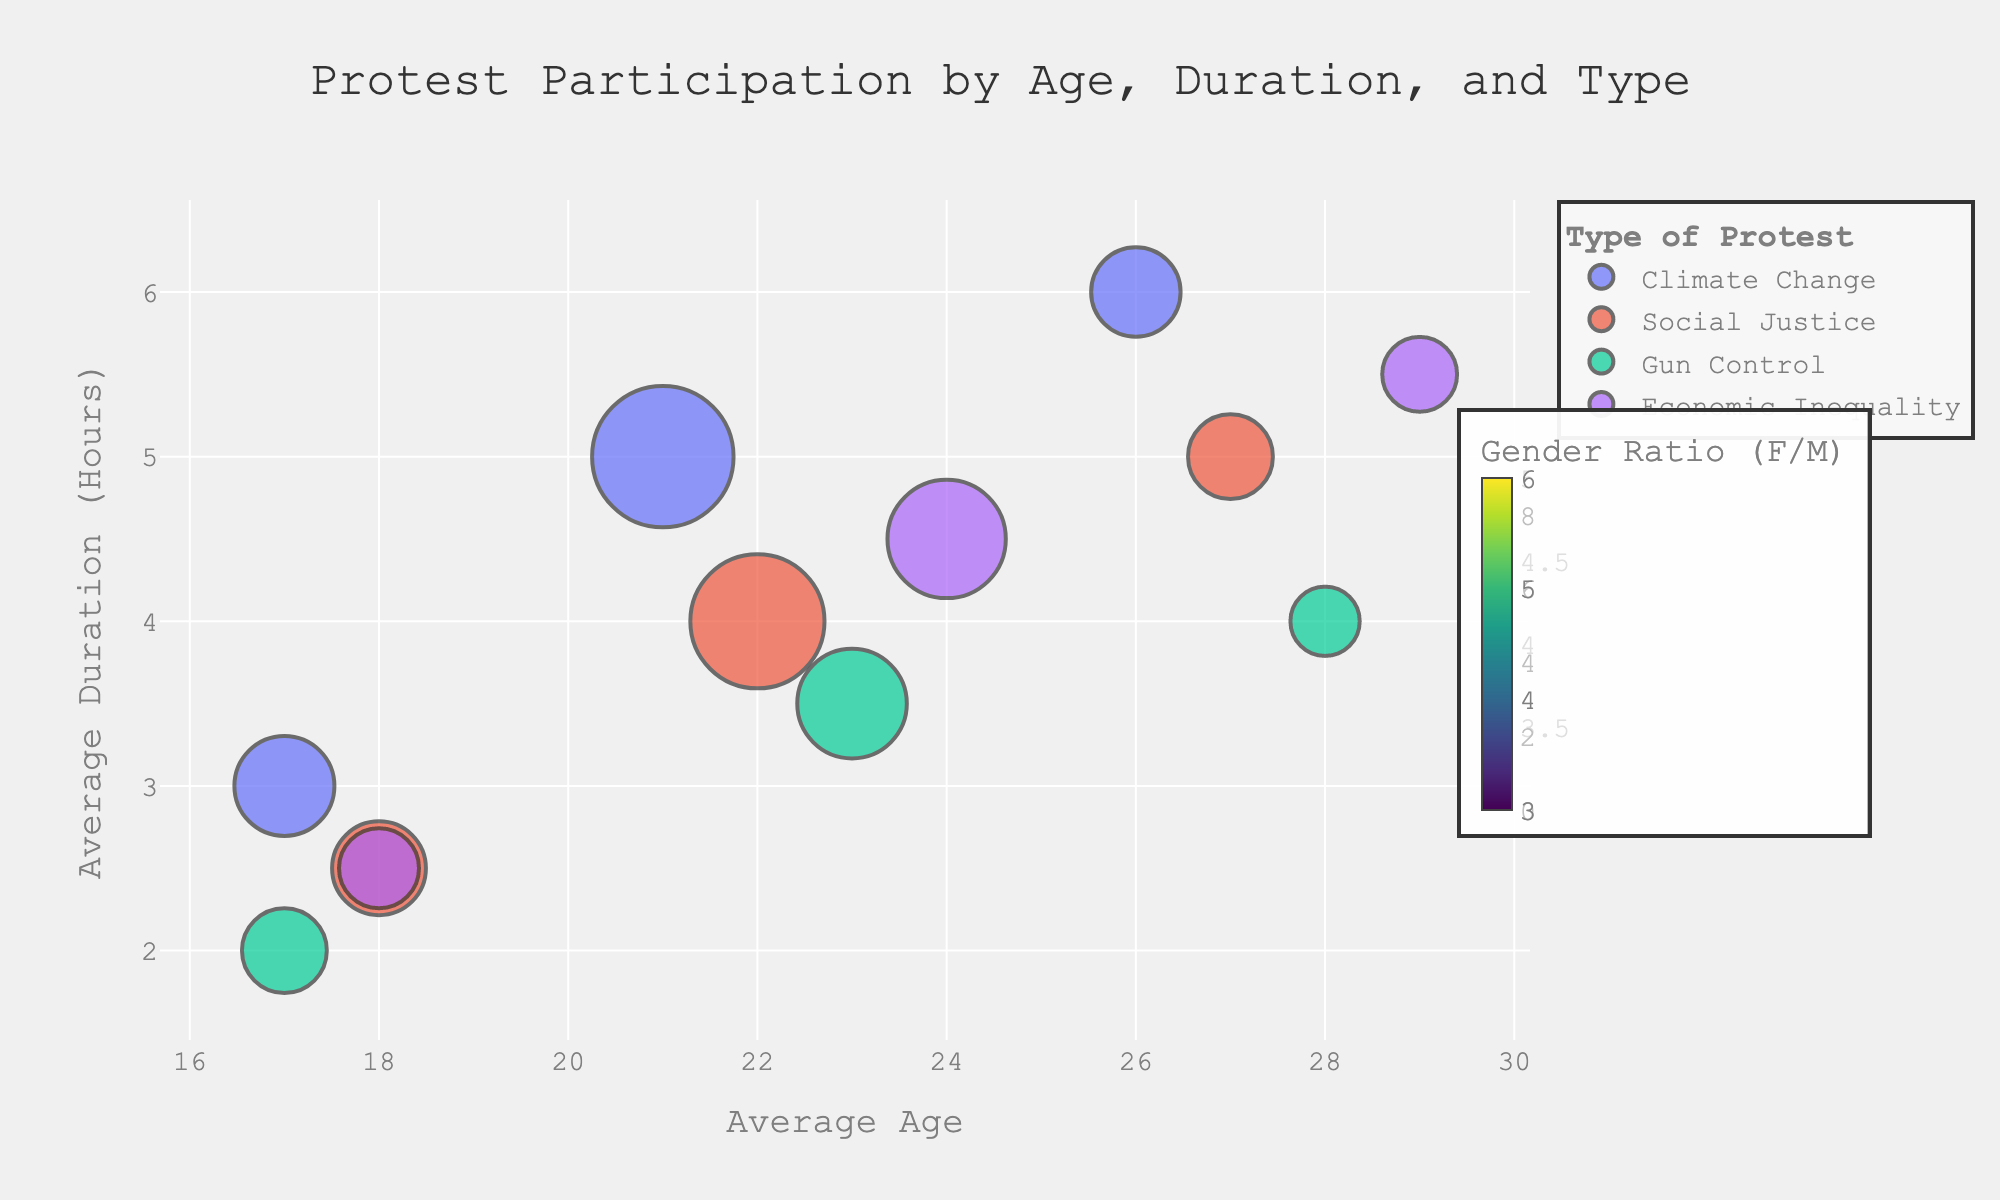what is the title of the chart? The title is located at the top of the chart and usually summarizes what the chart shows. In this case, it reads "Protest Participation by Age, Duration, and Type".
Answer: Protest Participation by Age, Duration, and Type how many different protest types are displayed? Each protest type is represented by a different color in the chart. By looking at the color legend, we can count the different categories: Climate Change, Social Justice, Gun Control, and Economic Inequality.
Answer: Four which demographic has the highest number of participants for climate change protests? Each bubble's size represents the number of participants, and the largest bubble for Climate Change can be identified by reading the data points. College Students have the highest participation with 500 participants.
Answer: College Students what is the average duration of Social Justice protests by young professionals? Locate the Social Justice bubbles for Young Professionals and check the y-axis value corresponding to Average Duration (Hours). It shows 5 hours for Young Professionals in Social Justice protests.
Answer: 5 hours how much older on average are young professionals compared to college students in Gun Control protests? Compare the age of Young Professionals and College Students for Gun Control protests. Look at the x-axis values: Young Professionals are 28 years old and College Students are 23 years old. Calculate the difference: 28 - 23 = 5.
Answer: 5 years which type of protest has the smallest average age for High School Students? Check the x-axis values for each protest type under the High School Students demographic, and identify the one with the lowest value. Climate Change has the smallest average age of 17.
Answer: Climate Change is there a notable difference in gender ratio for Economic Inequality protests between college students and high school students? Compare the GenderPercentageM and GenderPercentageF data provided in the hover information for Economic Inequality between these two demographics. College Students: 48% male, 52% female. High School Students: 48% male, 52% female. The ratios are essentially the same.
Answer: No which demographic has the shortest average duration for any protest type, and what is that duration? Locate the smallest value on the y-axis (Average Duration Hours) for all bubbles and identify the corresponding demographic and protest type. High School Students in Social Justice protests have the shortest average duration of 2.5 hours.
Answer: High School Students, 2.5 hours how does the gender balance in Social Justice protests compare between College Students and Young Professionals? Analyze the GenderPercentageM and GenderPercentageF for Social Justice between College Students (45% male, 55% female) and Young Professionals (50% male, 50% female). College students have a higher percentage of females, while Young professionals have an equal gender balance.
Answer: More balanced among Young Professionals 